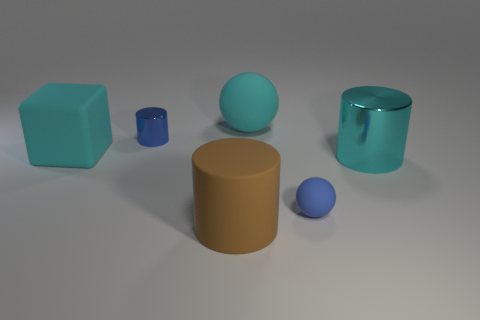What shape is the large brown rubber object?
Keep it short and to the point. Cylinder. How many things are either big things that are in front of the tiny metallic object or small gray shiny spheres?
Ensure brevity in your answer.  3. What number of other things are there of the same color as the big sphere?
Provide a short and direct response. 2. Does the large metallic thing have the same color as the cylinder in front of the large cyan shiny cylinder?
Provide a short and direct response. No. What color is the other big shiny thing that is the same shape as the brown thing?
Ensure brevity in your answer.  Cyan. Does the cube have the same material as the sphere that is behind the small blue matte ball?
Offer a very short reply. Yes. The tiny ball is what color?
Ensure brevity in your answer.  Blue. There is a metallic cylinder to the right of the sphere in front of the cylinder to the right of the large brown object; what color is it?
Make the answer very short. Cyan. There is a large brown rubber object; is its shape the same as the large rubber thing to the left of the tiny cylinder?
Make the answer very short. No. What is the color of the thing that is in front of the large metallic cylinder and right of the big sphere?
Make the answer very short. Blue. 